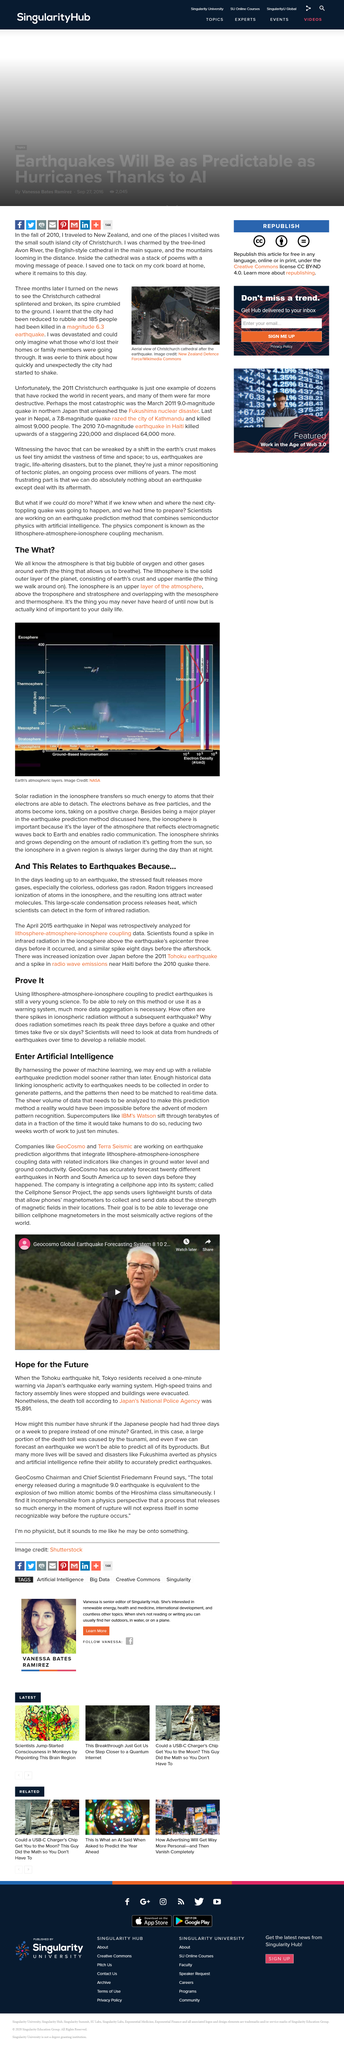Identify some key points in this picture. The New Zealand Defence Force is credited for the image and it is available on Wikimedia Commons. Ionization increases before an earthquake. The Fukushima earthquake occurred in Japan. Radon is a colorless, odorless gas that is often released in the lead up to an earthquake. Residents of Tokyo received only one minute of warning before the disaster struck. 